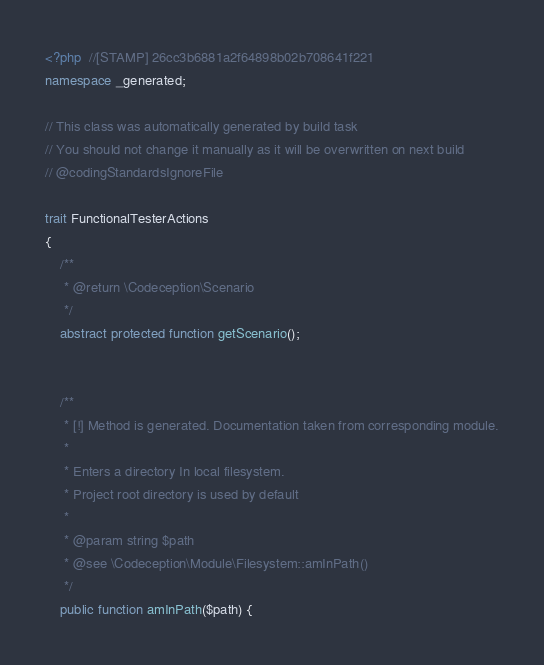Convert code to text. <code><loc_0><loc_0><loc_500><loc_500><_PHP_><?php  //[STAMP] 26cc3b6881a2f64898b02b708641f221
namespace _generated;

// This class was automatically generated by build task
// You should not change it manually as it will be overwritten on next build
// @codingStandardsIgnoreFile

trait FunctionalTesterActions
{
    /**
     * @return \Codeception\Scenario
     */
    abstract protected function getScenario();

    
    /**
     * [!] Method is generated. Documentation taken from corresponding module.
     *
     * Enters a directory In local filesystem.
     * Project root directory is used by default
     *
     * @param string $path
     * @see \Codeception\Module\Filesystem::amInPath()
     */
    public function amInPath($path) {</code> 